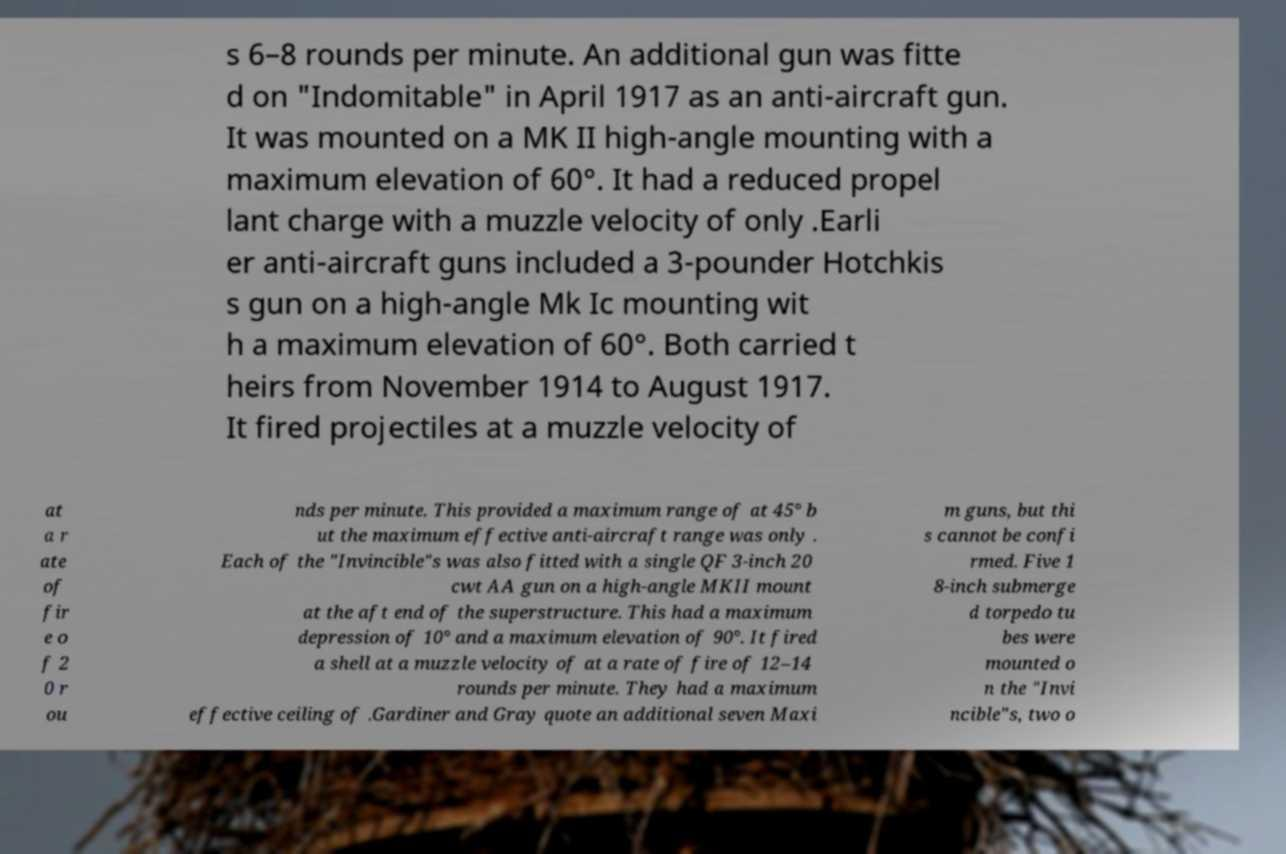Could you assist in decoding the text presented in this image and type it out clearly? s 6–8 rounds per minute. An additional gun was fitte d on "Indomitable" in April 1917 as an anti-aircraft gun. It was mounted on a MK II high-angle mounting with a maximum elevation of 60°. It had a reduced propel lant charge with a muzzle velocity of only .Earli er anti-aircraft guns included a 3-pounder Hotchkis s gun on a high-angle Mk Ic mounting wit h a maximum elevation of 60°. Both carried t heirs from November 1914 to August 1917. It fired projectiles at a muzzle velocity of at a r ate of fir e o f 2 0 r ou nds per minute. This provided a maximum range of at 45° b ut the maximum effective anti-aircraft range was only . Each of the "Invincible"s was also fitted with a single QF 3-inch 20 cwt AA gun on a high-angle MKII mount at the aft end of the superstructure. This had a maximum depression of 10° and a maximum elevation of 90°. It fired a shell at a muzzle velocity of at a rate of fire of 12–14 rounds per minute. They had a maximum effective ceiling of .Gardiner and Gray quote an additional seven Maxi m guns, but thi s cannot be confi rmed. Five 1 8-inch submerge d torpedo tu bes were mounted o n the "Invi ncible"s, two o 